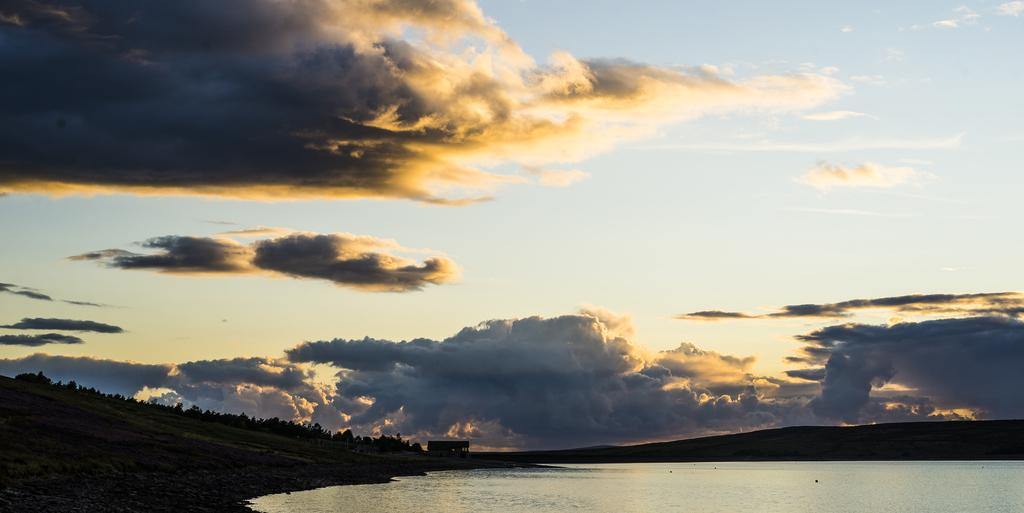What can be seen in the sky in the image? The sky and clouds are visible in the image. What type of structure is located near the river in the image? There is a shed near a river in the image. What is on the left side of the image? There is a mountain, trees, plants, and grass on the left side of the image. How many quinces are hanging from the trees on the left side of the image? There are no quinces present in the image; the trees on the left side of the image do not have any visible fruit. 